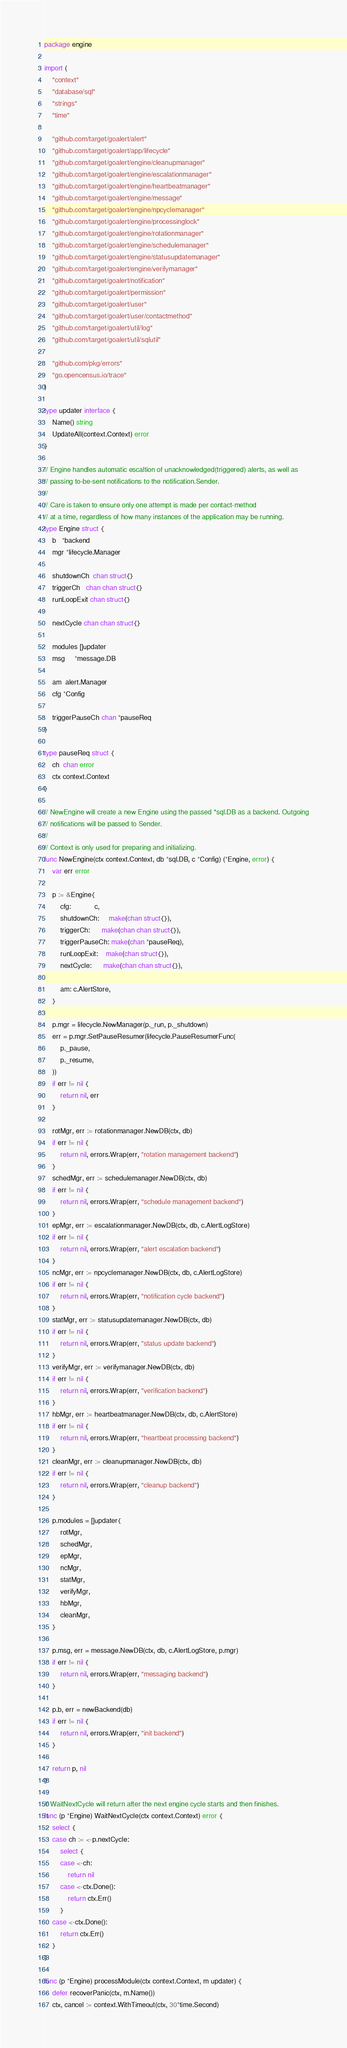Convert code to text. <code><loc_0><loc_0><loc_500><loc_500><_Go_>package engine

import (
	"context"
	"database/sql"
	"strings"
	"time"

	"github.com/target/goalert/alert"
	"github.com/target/goalert/app/lifecycle"
	"github.com/target/goalert/engine/cleanupmanager"
	"github.com/target/goalert/engine/escalationmanager"
	"github.com/target/goalert/engine/heartbeatmanager"
	"github.com/target/goalert/engine/message"
	"github.com/target/goalert/engine/npcyclemanager"
	"github.com/target/goalert/engine/processinglock"
	"github.com/target/goalert/engine/rotationmanager"
	"github.com/target/goalert/engine/schedulemanager"
	"github.com/target/goalert/engine/statusupdatemanager"
	"github.com/target/goalert/engine/verifymanager"
	"github.com/target/goalert/notification"
	"github.com/target/goalert/permission"
	"github.com/target/goalert/user"
	"github.com/target/goalert/user/contactmethod"
	"github.com/target/goalert/util/log"
	"github.com/target/goalert/util/sqlutil"

	"github.com/pkg/errors"
	"go.opencensus.io/trace"
)

type updater interface {
	Name() string
	UpdateAll(context.Context) error
}

// Engine handles automatic escaltion of unacknowledged(triggered) alerts, as well as
// passing to-be-sent notifications to the notification.Sender.
//
// Care is taken to ensure only one attempt is made per contact-method
// at a time, regardless of how many instances of the application may be running.
type Engine struct {
	b   *backend
	mgr *lifecycle.Manager

	shutdownCh  chan struct{}
	triggerCh   chan chan struct{}
	runLoopExit chan struct{}

	nextCycle chan chan struct{}

	modules []updater
	msg     *message.DB

	am  alert.Manager
	cfg *Config

	triggerPauseCh chan *pauseReq
}

type pauseReq struct {
	ch  chan error
	ctx context.Context
}

// NewEngine will create a new Engine using the passed *sql.DB as a backend. Outgoing
// notifications will be passed to Sender.
//
// Context is only used for preparing and initializing.
func NewEngine(ctx context.Context, db *sql.DB, c *Config) (*Engine, error) {
	var err error

	p := &Engine{
		cfg:            c,
		shutdownCh:     make(chan struct{}),
		triggerCh:      make(chan chan struct{}),
		triggerPauseCh: make(chan *pauseReq),
		runLoopExit:    make(chan struct{}),
		nextCycle:      make(chan chan struct{}),

		am: c.AlertStore,
	}

	p.mgr = lifecycle.NewManager(p._run, p._shutdown)
	err = p.mgr.SetPauseResumer(lifecycle.PauseResumerFunc(
		p._pause,
		p._resume,
	))
	if err != nil {
		return nil, err
	}

	rotMgr, err := rotationmanager.NewDB(ctx, db)
	if err != nil {
		return nil, errors.Wrap(err, "rotation management backend")
	}
	schedMgr, err := schedulemanager.NewDB(ctx, db)
	if err != nil {
		return nil, errors.Wrap(err, "schedule management backend")
	}
	epMgr, err := escalationmanager.NewDB(ctx, db, c.AlertLogStore)
	if err != nil {
		return nil, errors.Wrap(err, "alert escalation backend")
	}
	ncMgr, err := npcyclemanager.NewDB(ctx, db, c.AlertLogStore)
	if err != nil {
		return nil, errors.Wrap(err, "notification cycle backend")
	}
	statMgr, err := statusupdatemanager.NewDB(ctx, db)
	if err != nil {
		return nil, errors.Wrap(err, "status update backend")
	}
	verifyMgr, err := verifymanager.NewDB(ctx, db)
	if err != nil {
		return nil, errors.Wrap(err, "verification backend")
	}
	hbMgr, err := heartbeatmanager.NewDB(ctx, db, c.AlertStore)
	if err != nil {
		return nil, errors.Wrap(err, "heartbeat processing backend")
	}
	cleanMgr, err := cleanupmanager.NewDB(ctx, db)
	if err != nil {
		return nil, errors.Wrap(err, "cleanup backend")
	}

	p.modules = []updater{
		rotMgr,
		schedMgr,
		epMgr,
		ncMgr,
		statMgr,
		verifyMgr,
		hbMgr,
		cleanMgr,
	}

	p.msg, err = message.NewDB(ctx, db, c.AlertLogStore, p.mgr)
	if err != nil {
		return nil, errors.Wrap(err, "messaging backend")
	}

	p.b, err = newBackend(db)
	if err != nil {
		return nil, errors.Wrap(err, "init backend")
	}

	return p, nil
}

// WaitNextCycle will return after the next engine cycle starts and then finishes.
func (p *Engine) WaitNextCycle(ctx context.Context) error {
	select {
	case ch := <-p.nextCycle:
		select {
		case <-ch:
			return nil
		case <-ctx.Done():
			return ctx.Err()
		}
	case <-ctx.Done():
		return ctx.Err()
	}
}

func (p *Engine) processModule(ctx context.Context, m updater) {
	defer recoverPanic(ctx, m.Name())
	ctx, cancel := context.WithTimeout(ctx, 30*time.Second)</code> 